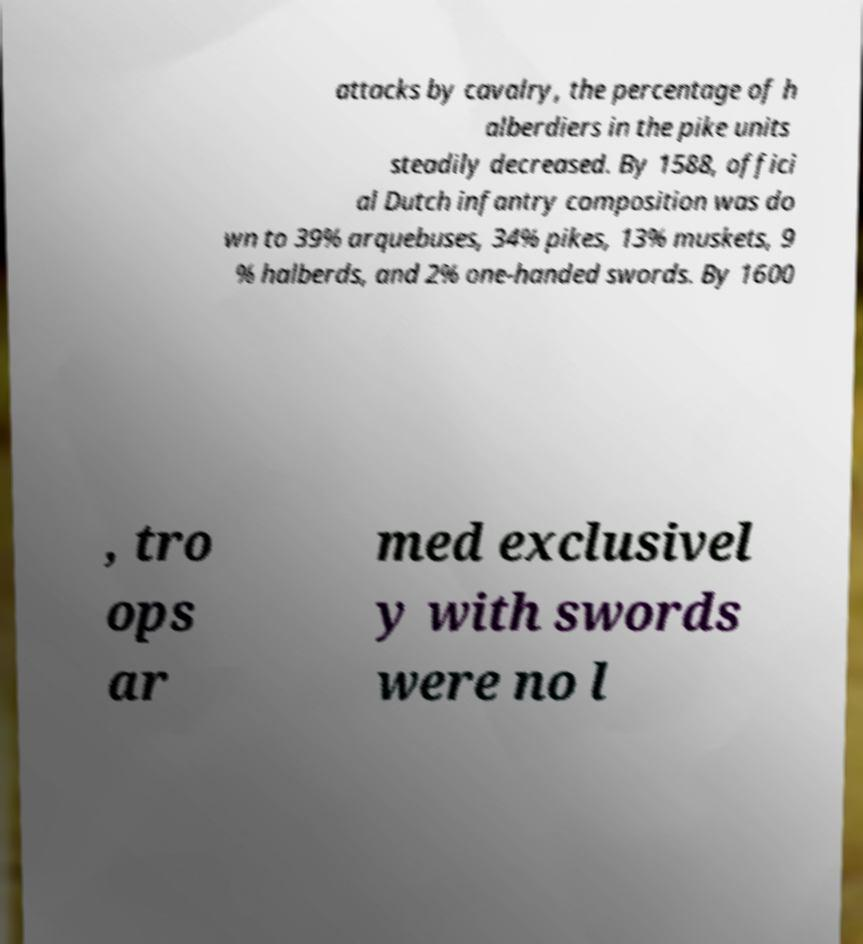Can you read and provide the text displayed in the image?This photo seems to have some interesting text. Can you extract and type it out for me? attacks by cavalry, the percentage of h alberdiers in the pike units steadily decreased. By 1588, offici al Dutch infantry composition was do wn to 39% arquebuses, 34% pikes, 13% muskets, 9 % halberds, and 2% one-handed swords. By 1600 , tro ops ar med exclusivel y with swords were no l 